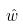Convert formula to latex. <formula><loc_0><loc_0><loc_500><loc_500>\hat { w }</formula> 